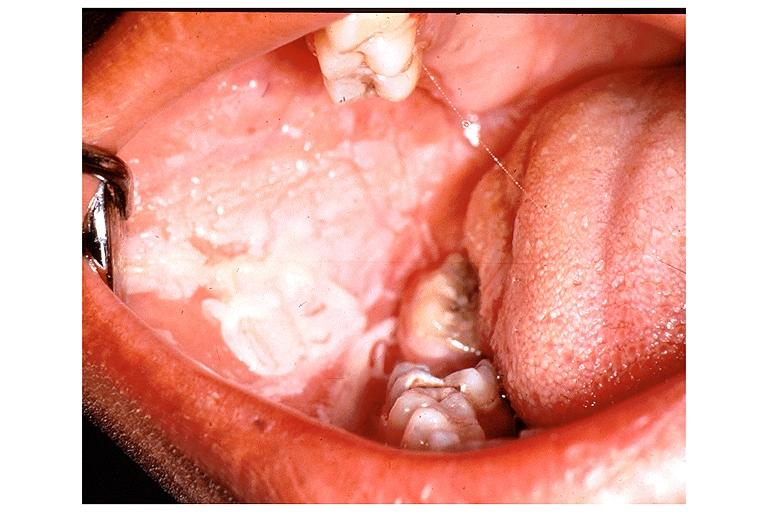what is present?
Answer the question using a single word or phrase. Oral 